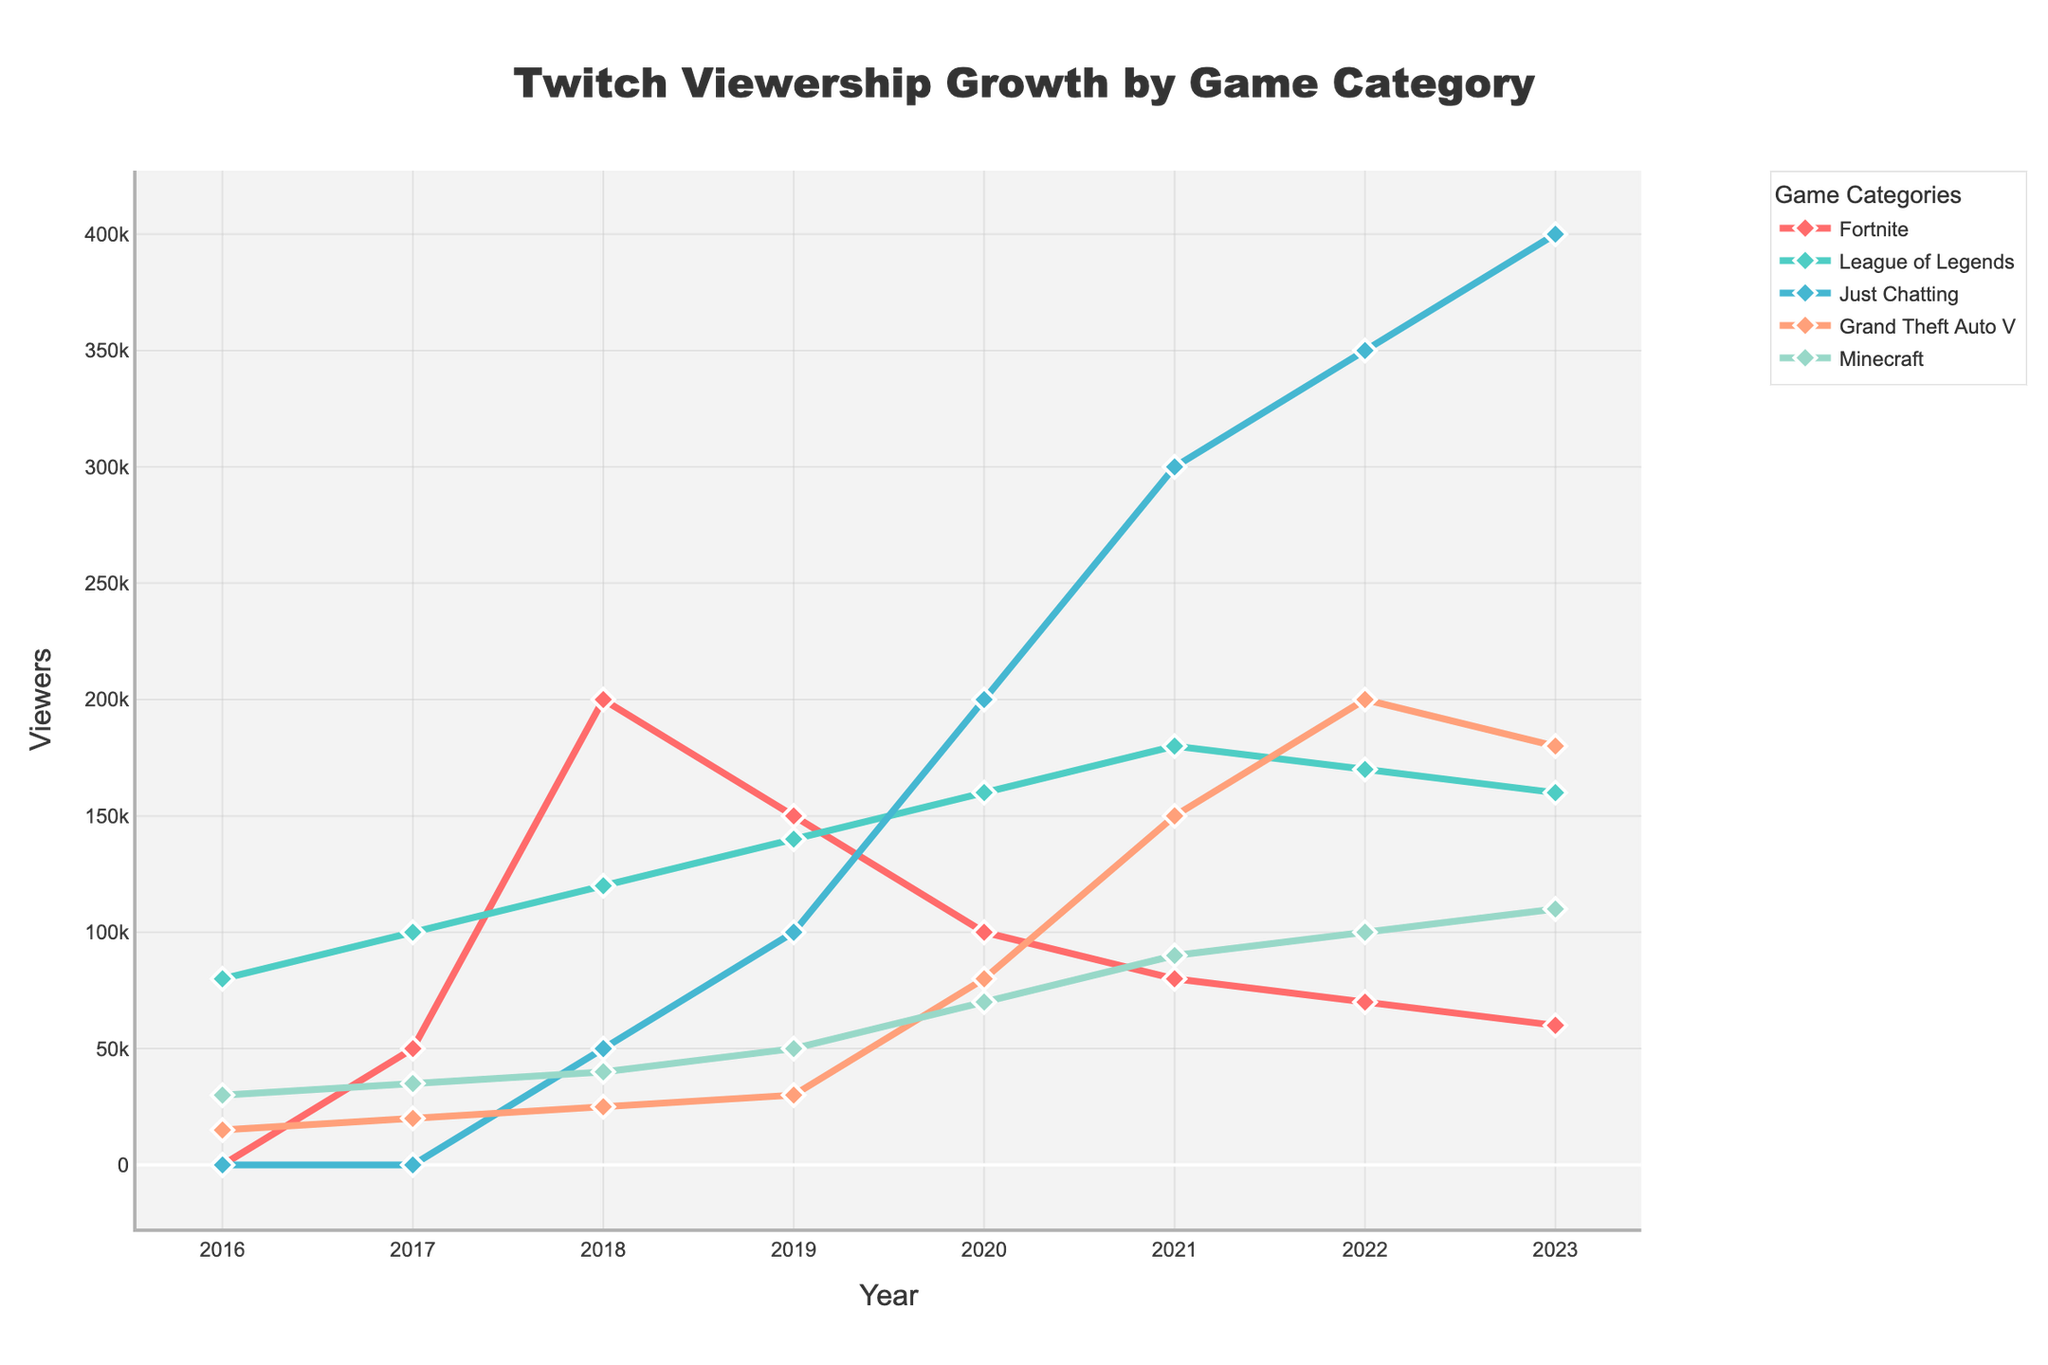What year did 'Just Chatting' first start appearing in the data? 'Just Chatting' first appears in the year 2018. By looking at the line for 'Just Chatting', it starts at zero participation before 2018 and shows a value starting from that year.
Answer: 2018 Which game category had the highest peak viewership in 2023? By observing the highest points on the lines representing each game category in 2023, 'Just Chatting' reaches the highest viewership with 400,000 viewers.
Answer: Just Chatting How has the viewership trend for 'Fortnite' changed from 2018 to 2023? The viewership for 'Fortnite' decreases over this period. It starts at 200,000 in 2018 and gradually declines to 60,000 by 2023, as indicated by the downward slope of the 'Fortnite' line.
Answer: Decreasing What is the difference in viewership between 'League of Legends' and 'Minecraft' in 2023? In 2023, 'League of Legends' has 160,000 viewers and 'Minecraft' has 110,000 viewers. The difference is calculated as 160,000 - 110,000 = 50,000.
Answer: 50,000 Which game category experienced the highest growth between 2019 and 2023? By measuring the differences in viewership from 2019 to 2023 for each game, 'Just Chatting' shows the highest growth, increasing from 100,000 viewers in 2019 to 400,000 viewers in 2023, which is a growth of 300,000.
Answer: Just Chatting Compare the viewership of 'Grand Theft Auto V' in 2020 and 2021. Which year had a higher viewership, and by how much? 'Grand Theft Auto V' had 80,000 viewers in 2020 and 150,000 viewers in 2021. The increase from 2020 to 2021 is 150,000 - 80,000 = 70,000.
Answer: 2021, 70,000 What was the average viewership for 'Minecraft' from 2016 to 2023? Summing the values for 'Minecraft' from 2016 to 2023 gives 30,000 + 35,000 + 40,000 + 50,000 + 70,000 + 90,000 + 100,000 + 110,000 = 525,000. Dividing by the number of years (8), the average viewership is 525,000 / 8 = 65,625.
Answer: 65,625 Which category saw a decline in viewership from 2021 to 2022, and by how much? 'League of Legends' had 180,000 viewers in 2021 and 170,000 in 2022, a decline of 10,000. Similarly, 'Just Chatting' declined from 300,000 to 350,000, not a decline. 'Grand Theft Auto V' increased. 'Fortnite' decreased from 80,000 to 70,000, but the decline is lesser than 'League of Legends'.
Answer: League of Legends, 10,000 